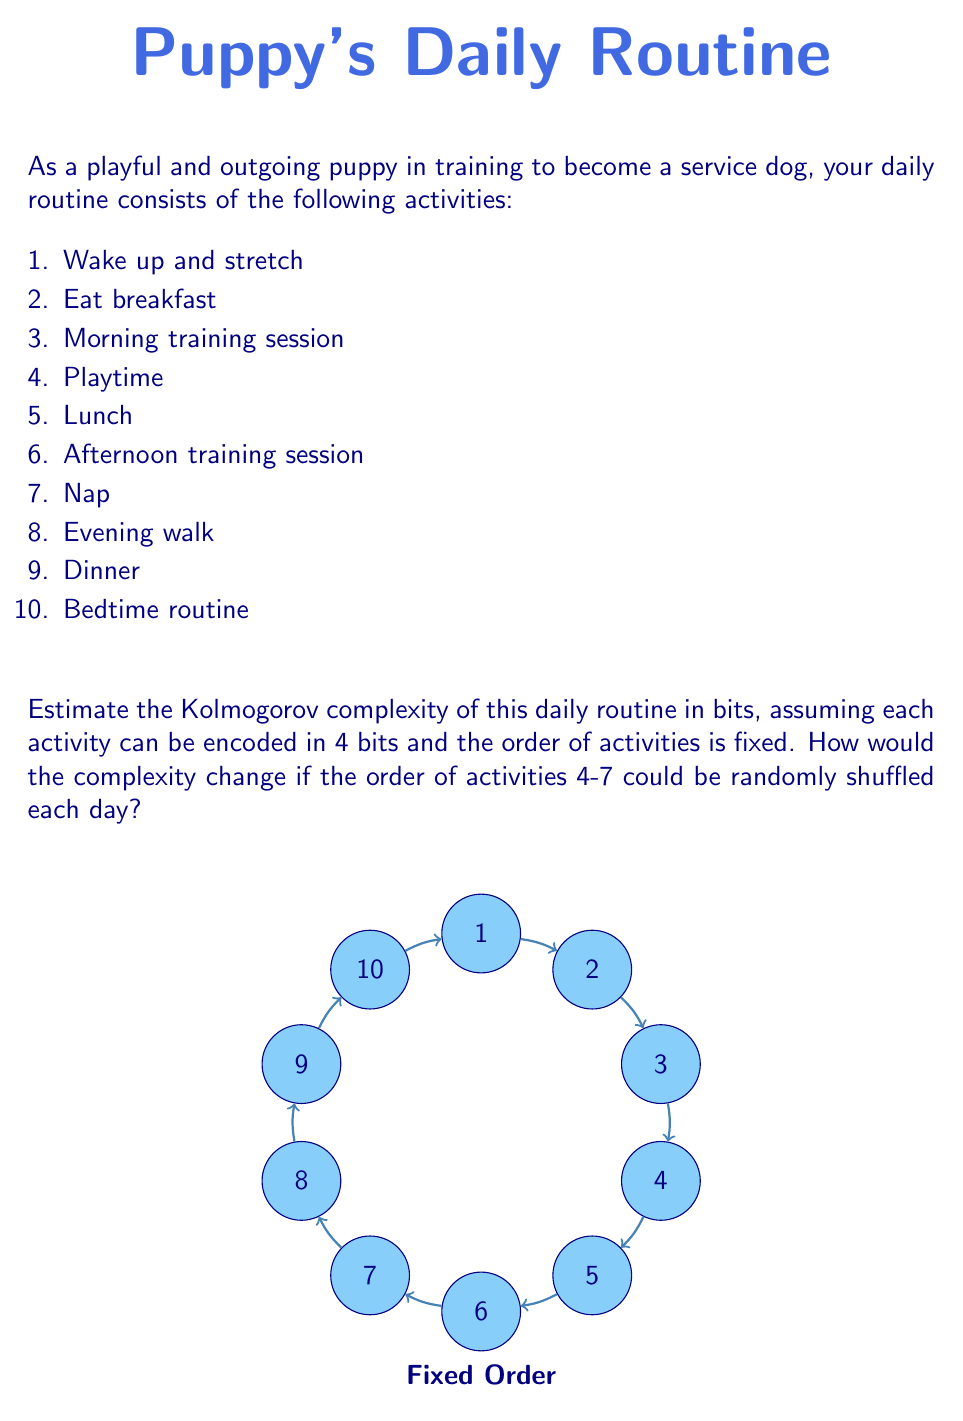Show me your answer to this math problem. Let's approach this problem step-by-step:

1) First, let's calculate the Kolmogorov complexity for the fixed routine:

   Each activity requires 4 bits to encode.
   There are 10 activities in total.
   
   So, the total number of bits needed is:
   
   $$10 \times 4 = 40 \text{ bits}$$

2) Now, let's consider the case where activities 4-7 can be randomly shuffled:

   Activities 1-3 and 8-10 remain fixed, requiring:
   $$6 \times 4 = 24 \text{ bits}$$

   For activities 4-7, we need to consider two components:
   a) The bits to encode the activities themselves: $4 \times 4 = 16 \text{ bits}$
   b) The bits to encode the order of these activities

   To encode the order of 4 activities, we need to consider the number of possible permutations:
   $$4! = 24 \text{ permutations}$$

   The number of bits needed to represent 24 distinct values is:
   $$\lceil \log_2(24) \rceil = 5 \text{ bits}$$

   Therefore, the total Kolmogorov complexity in the shuffled case is:
   $$24 + 16 + 5 = 45 \text{ bits}$$

3) The change in complexity is:
   $$45 - 40 = 5 \text{ bits}$$

This increase represents the additional information needed to specify the order of the shuffled activities each day.
Answer: Fixed: 40 bits; Shuffled: 45 bits; Increase: 5 bits 